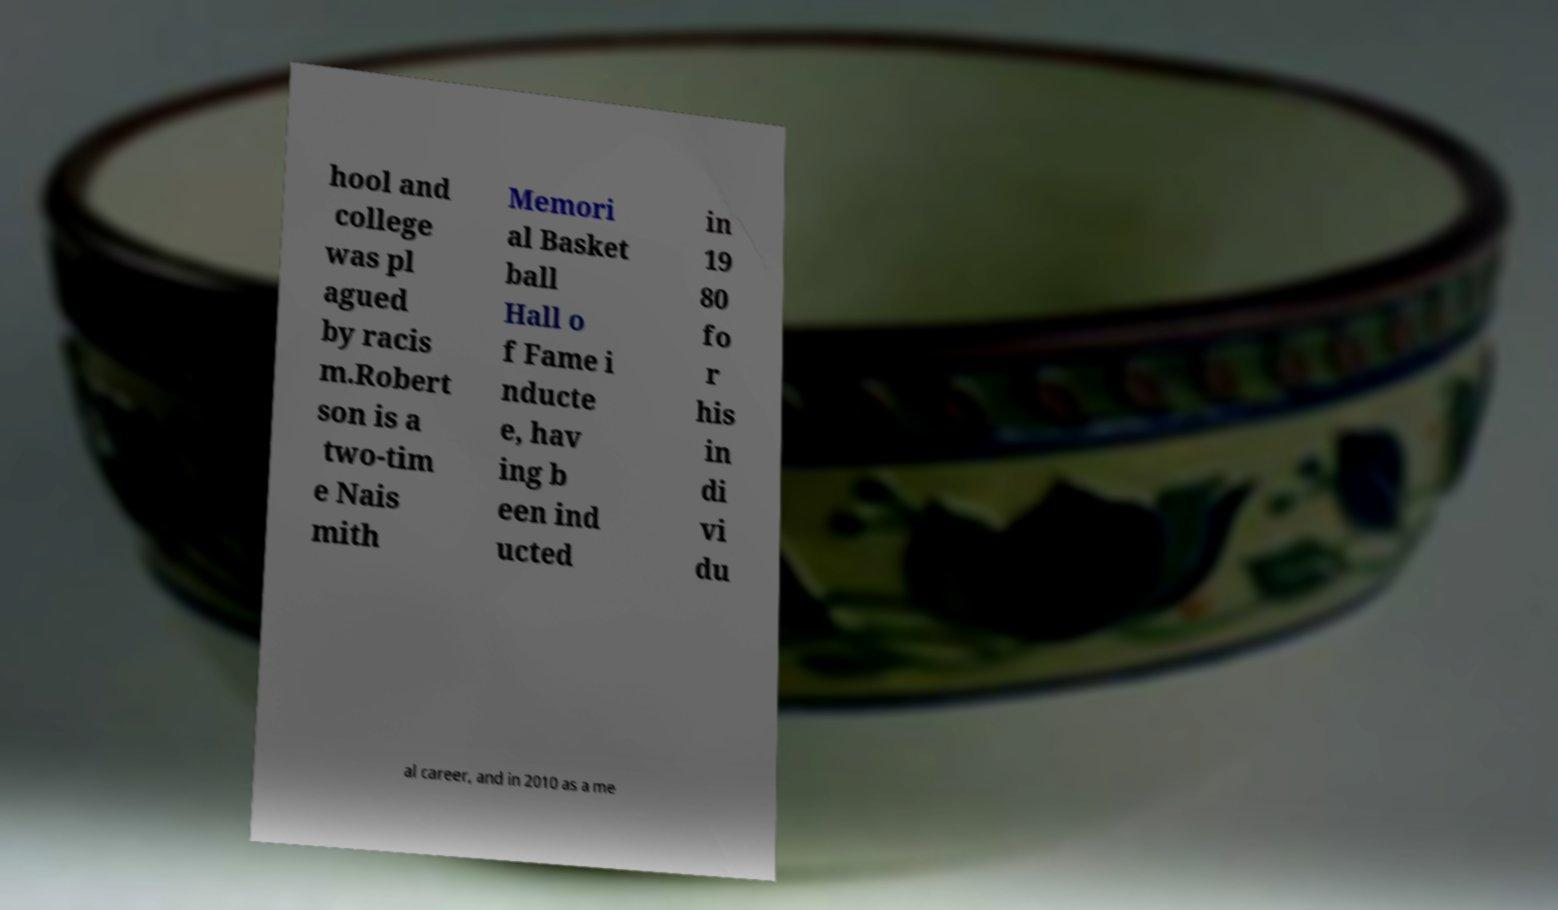For documentation purposes, I need the text within this image transcribed. Could you provide that? hool and college was pl agued by racis m.Robert son is a two-tim e Nais mith Memori al Basket ball Hall o f Fame i nducte e, hav ing b een ind ucted in 19 80 fo r his in di vi du al career, and in 2010 as a me 